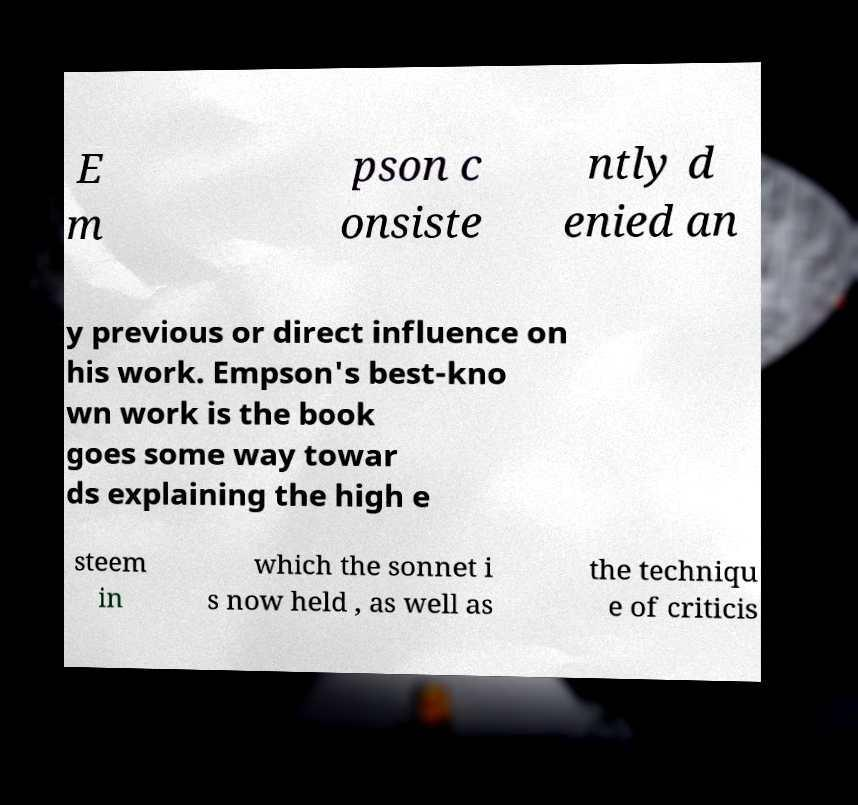Can you read and provide the text displayed in the image?This photo seems to have some interesting text. Can you extract and type it out for me? E m pson c onsiste ntly d enied an y previous or direct influence on his work. Empson's best-kno wn work is the book goes some way towar ds explaining the high e steem in which the sonnet i s now held , as well as the techniqu e of criticis 